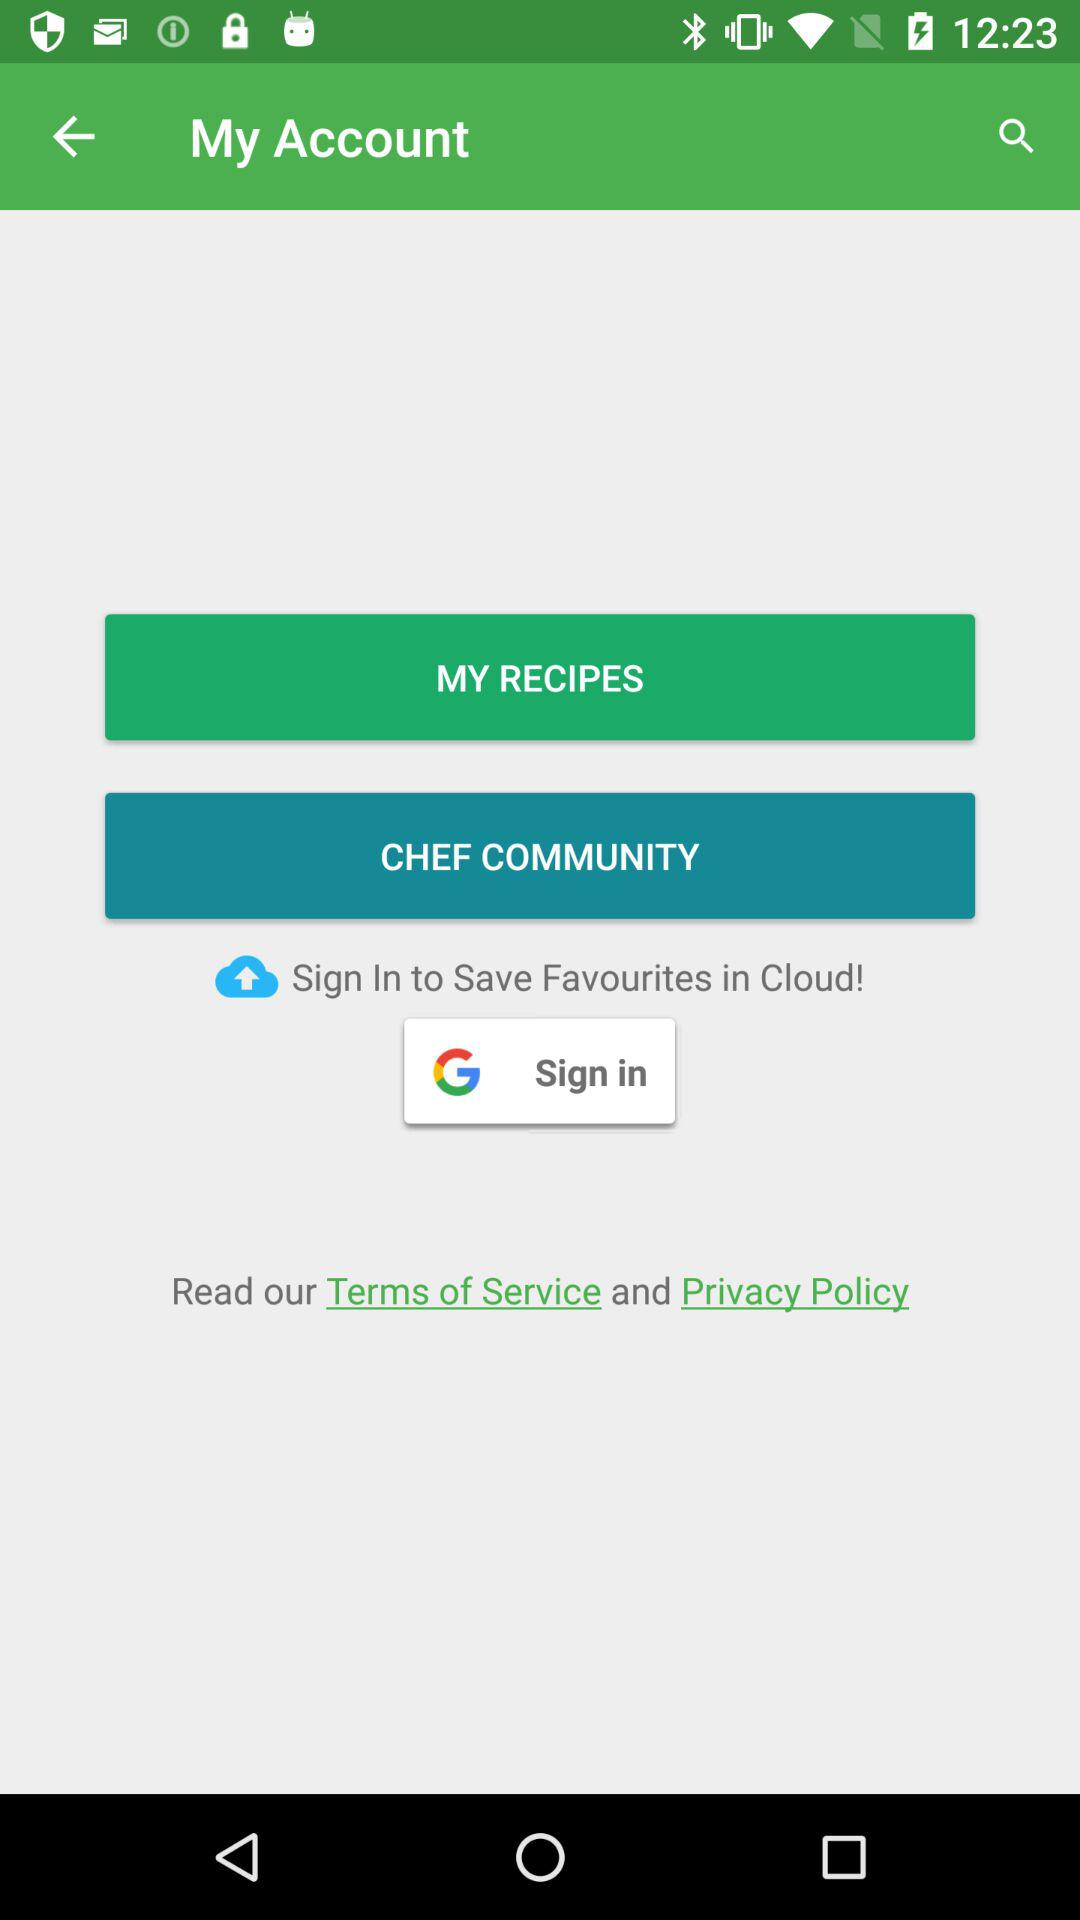What application can be used to sign in? The application that can be used to sign in is "Google". 